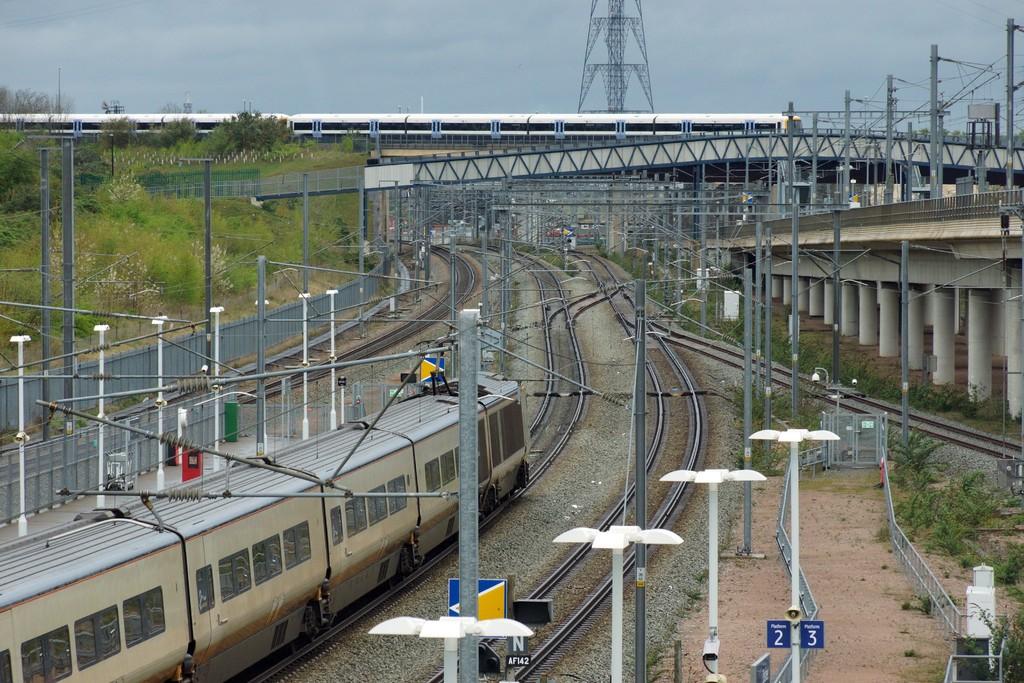What number is the platform?
Make the answer very short. 2 and 3. 